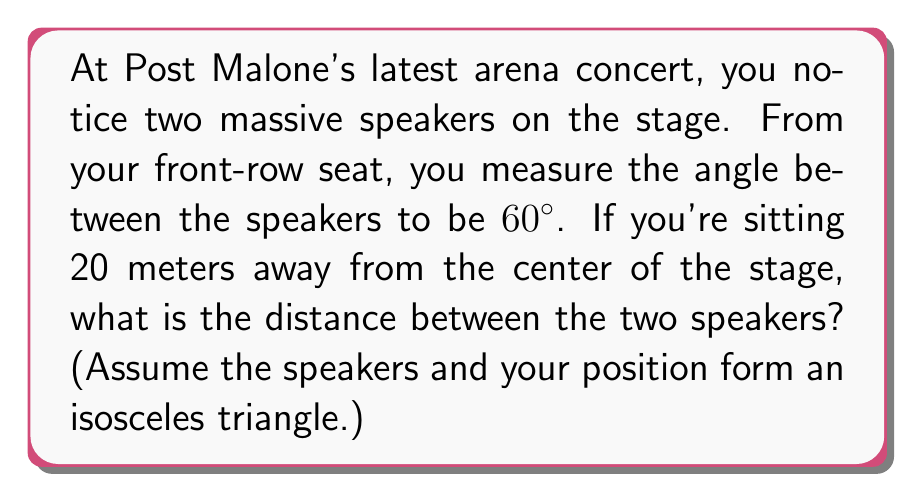Show me your answer to this math problem. Let's approach this step-by-step:

1) First, let's visualize the problem:

[asy]
import geometry;

size(200);

pair A = (0,0);
pair B = (100,0);
pair C = (50,86.6);

draw(A--B--C--A);

label("You", (50,-10), S);
label("Speaker 1", A, W);
label("Speaker 2", B, E);
label("20m", (50,43.3), E);
label("60°", C, N);

dot(A);
dot(B);
dot(C);
[/asy]

2) We have an isosceles triangle where:
   - The base is the distance between the speakers (let's call this $x$)
   - The two equal sides are 20 meters (your distance from the stage center)
   - The angle at the top is 60°

3) We can split this isosceles triangle into two right triangles. In one of these right triangles:
   - The hypotenuse is 20m
   - The angle at the top is 30° (half of 60°)
   - We need to find half of $x$ (let's call this $\frac{x}{2}$)

4) In a right triangle, cosine of an angle is the adjacent side divided by the hypotenuse:

   $$\cos 30° = \frac{\text{adjacent}}{\text{hypotenuse}} = \frac{\frac{x}{2}}{20}$$

5) We know that $\cos 30° = \frac{\sqrt{3}}{2}$, so:

   $$\frac{\sqrt{3}}{2} = \frac{\frac{x}{2}}{20}$$

6) Solve for $x$:
   $$x = 20 \cdot 2 \cdot \frac{\sqrt{3}}{2} = 20\sqrt{3}$$

7) Therefore, the distance between the speakers is $20\sqrt{3}$ meters.
Answer: $20\sqrt{3}$ meters 